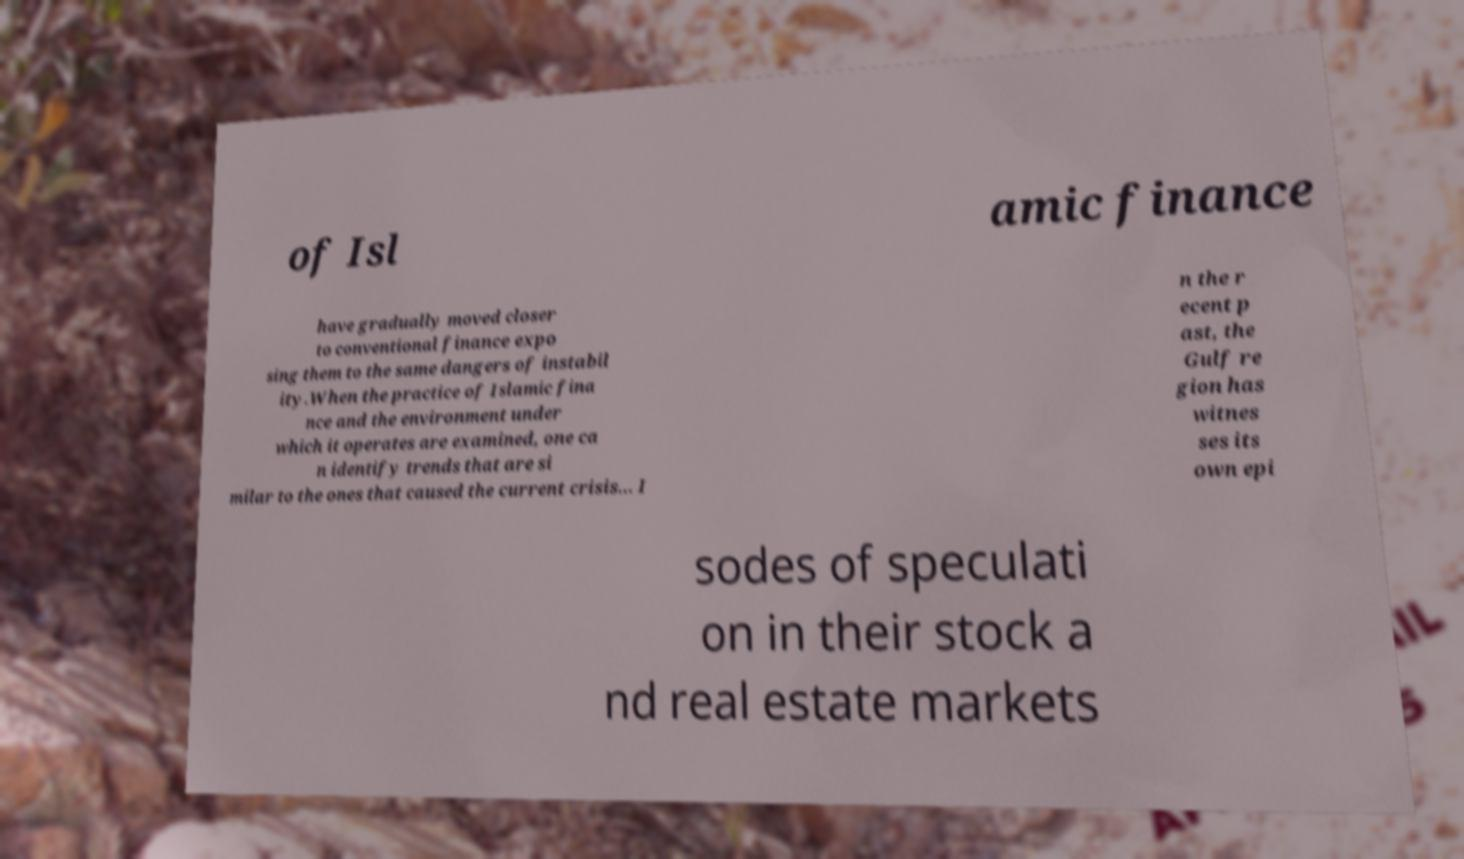Could you extract and type out the text from this image? of Isl amic finance have gradually moved closer to conventional finance expo sing them to the same dangers of instabil ity.When the practice of Islamic fina nce and the environment under which it operates are examined, one ca n identify trends that are si milar to the ones that caused the current crisis... I n the r ecent p ast, the Gulf re gion has witnes ses its own epi sodes of speculati on in their stock a nd real estate markets 